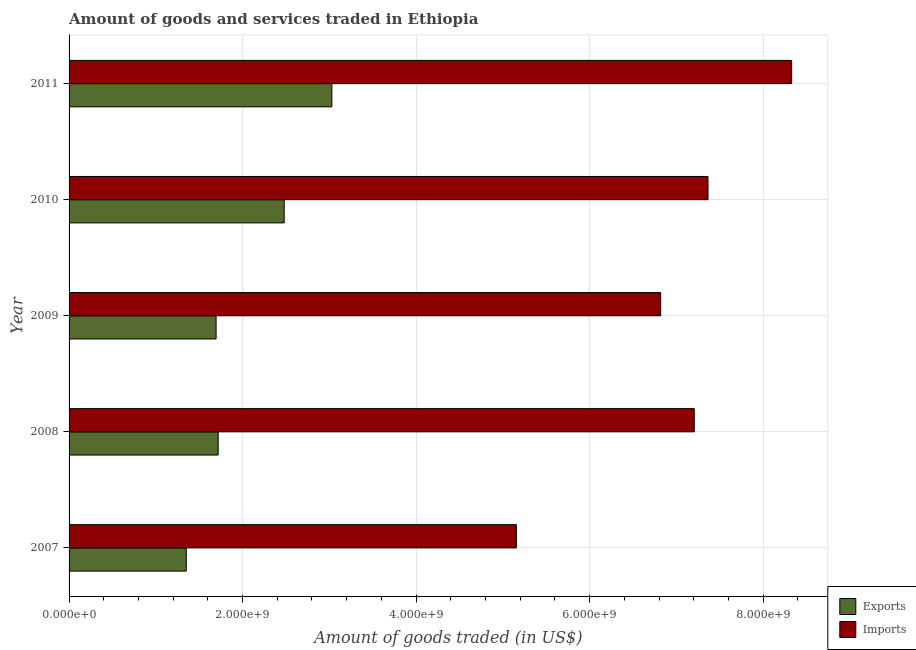How many different coloured bars are there?
Provide a short and direct response. 2. How many groups of bars are there?
Offer a terse response. 5. How many bars are there on the 5th tick from the bottom?
Your answer should be compact. 2. What is the amount of goods exported in 2007?
Offer a very short reply. 1.35e+09. Across all years, what is the maximum amount of goods exported?
Provide a short and direct response. 3.03e+09. Across all years, what is the minimum amount of goods imported?
Ensure brevity in your answer.  5.16e+09. In which year was the amount of goods imported maximum?
Give a very brief answer. 2011. What is the total amount of goods imported in the graph?
Make the answer very short. 3.49e+1. What is the difference between the amount of goods exported in 2010 and that in 2011?
Your answer should be very brief. -5.50e+08. What is the difference between the amount of goods exported in 2007 and the amount of goods imported in 2011?
Keep it short and to the point. -6.98e+09. What is the average amount of goods exported per year?
Provide a short and direct response. 2.05e+09. In the year 2010, what is the difference between the amount of goods exported and amount of goods imported?
Give a very brief answer. -4.89e+09. What is the ratio of the amount of goods exported in 2009 to that in 2010?
Give a very brief answer. 0.68. Is the amount of goods imported in 2008 less than that in 2009?
Your response must be concise. No. What is the difference between the highest and the second highest amount of goods exported?
Give a very brief answer. 5.50e+08. What is the difference between the highest and the lowest amount of goods exported?
Provide a short and direct response. 1.68e+09. What does the 2nd bar from the top in 2009 represents?
Provide a succinct answer. Exports. What does the 2nd bar from the bottom in 2008 represents?
Ensure brevity in your answer.  Imports. How many bars are there?
Your answer should be very brief. 10. Are all the bars in the graph horizontal?
Ensure brevity in your answer.  Yes. What is the difference between two consecutive major ticks on the X-axis?
Provide a succinct answer. 2.00e+09. Are the values on the major ticks of X-axis written in scientific E-notation?
Make the answer very short. Yes. Does the graph contain any zero values?
Ensure brevity in your answer.  No. Where does the legend appear in the graph?
Make the answer very short. Bottom right. How many legend labels are there?
Your answer should be compact. 2. What is the title of the graph?
Offer a terse response. Amount of goods and services traded in Ethiopia. What is the label or title of the X-axis?
Provide a succinct answer. Amount of goods traded (in US$). What is the Amount of goods traded (in US$) of Exports in 2007?
Your answer should be very brief. 1.35e+09. What is the Amount of goods traded (in US$) of Imports in 2007?
Provide a short and direct response. 5.16e+09. What is the Amount of goods traded (in US$) in Exports in 2008?
Keep it short and to the point. 1.72e+09. What is the Amount of goods traded (in US$) of Imports in 2008?
Your answer should be very brief. 7.21e+09. What is the Amount of goods traded (in US$) in Exports in 2009?
Offer a very short reply. 1.69e+09. What is the Amount of goods traded (in US$) in Imports in 2009?
Your response must be concise. 6.82e+09. What is the Amount of goods traded (in US$) of Exports in 2010?
Keep it short and to the point. 2.48e+09. What is the Amount of goods traded (in US$) of Imports in 2010?
Offer a very short reply. 7.36e+09. What is the Amount of goods traded (in US$) in Exports in 2011?
Your response must be concise. 3.03e+09. What is the Amount of goods traded (in US$) in Imports in 2011?
Make the answer very short. 8.33e+09. Across all years, what is the maximum Amount of goods traded (in US$) in Exports?
Provide a short and direct response. 3.03e+09. Across all years, what is the maximum Amount of goods traded (in US$) in Imports?
Provide a short and direct response. 8.33e+09. Across all years, what is the minimum Amount of goods traded (in US$) in Exports?
Your answer should be compact. 1.35e+09. Across all years, what is the minimum Amount of goods traded (in US$) in Imports?
Your answer should be very brief. 5.16e+09. What is the total Amount of goods traded (in US$) of Exports in the graph?
Give a very brief answer. 1.03e+1. What is the total Amount of goods traded (in US$) in Imports in the graph?
Your answer should be very brief. 3.49e+1. What is the difference between the Amount of goods traded (in US$) of Exports in 2007 and that in 2008?
Your answer should be compact. -3.68e+08. What is the difference between the Amount of goods traded (in US$) of Imports in 2007 and that in 2008?
Your response must be concise. -2.05e+09. What is the difference between the Amount of goods traded (in US$) of Exports in 2007 and that in 2009?
Your answer should be compact. -3.44e+08. What is the difference between the Amount of goods traded (in US$) in Imports in 2007 and that in 2009?
Keep it short and to the point. -1.66e+09. What is the difference between the Amount of goods traded (in US$) in Exports in 2007 and that in 2010?
Your answer should be very brief. -1.13e+09. What is the difference between the Amount of goods traded (in US$) of Imports in 2007 and that in 2010?
Keep it short and to the point. -2.21e+09. What is the difference between the Amount of goods traded (in US$) of Exports in 2007 and that in 2011?
Provide a short and direct response. -1.68e+09. What is the difference between the Amount of goods traded (in US$) of Imports in 2007 and that in 2011?
Provide a succinct answer. -3.17e+09. What is the difference between the Amount of goods traded (in US$) in Exports in 2008 and that in 2009?
Give a very brief answer. 2.39e+07. What is the difference between the Amount of goods traded (in US$) in Imports in 2008 and that in 2009?
Give a very brief answer. 3.87e+08. What is the difference between the Amount of goods traded (in US$) of Exports in 2008 and that in 2010?
Give a very brief answer. -7.61e+08. What is the difference between the Amount of goods traded (in US$) in Imports in 2008 and that in 2010?
Your response must be concise. -1.58e+08. What is the difference between the Amount of goods traded (in US$) in Exports in 2008 and that in 2011?
Your answer should be compact. -1.31e+09. What is the difference between the Amount of goods traded (in US$) in Imports in 2008 and that in 2011?
Provide a short and direct response. -1.12e+09. What is the difference between the Amount of goods traded (in US$) of Exports in 2009 and that in 2010?
Provide a succinct answer. -7.85e+08. What is the difference between the Amount of goods traded (in US$) of Imports in 2009 and that in 2010?
Provide a short and direct response. -5.45e+08. What is the difference between the Amount of goods traded (in US$) of Exports in 2009 and that in 2011?
Your answer should be very brief. -1.33e+09. What is the difference between the Amount of goods traded (in US$) in Imports in 2009 and that in 2011?
Your answer should be very brief. -1.51e+09. What is the difference between the Amount of goods traded (in US$) of Exports in 2010 and that in 2011?
Keep it short and to the point. -5.50e+08. What is the difference between the Amount of goods traded (in US$) in Imports in 2010 and that in 2011?
Provide a short and direct response. -9.64e+08. What is the difference between the Amount of goods traded (in US$) in Exports in 2007 and the Amount of goods traded (in US$) in Imports in 2008?
Offer a terse response. -5.86e+09. What is the difference between the Amount of goods traded (in US$) in Exports in 2007 and the Amount of goods traded (in US$) in Imports in 2009?
Provide a short and direct response. -5.47e+09. What is the difference between the Amount of goods traded (in US$) of Exports in 2007 and the Amount of goods traded (in US$) of Imports in 2010?
Give a very brief answer. -6.01e+09. What is the difference between the Amount of goods traded (in US$) in Exports in 2007 and the Amount of goods traded (in US$) in Imports in 2011?
Offer a terse response. -6.98e+09. What is the difference between the Amount of goods traded (in US$) in Exports in 2008 and the Amount of goods traded (in US$) in Imports in 2009?
Ensure brevity in your answer.  -5.10e+09. What is the difference between the Amount of goods traded (in US$) of Exports in 2008 and the Amount of goods traded (in US$) of Imports in 2010?
Offer a very short reply. -5.65e+09. What is the difference between the Amount of goods traded (in US$) of Exports in 2008 and the Amount of goods traded (in US$) of Imports in 2011?
Keep it short and to the point. -6.61e+09. What is the difference between the Amount of goods traded (in US$) of Exports in 2009 and the Amount of goods traded (in US$) of Imports in 2010?
Your answer should be compact. -5.67e+09. What is the difference between the Amount of goods traded (in US$) in Exports in 2009 and the Amount of goods traded (in US$) in Imports in 2011?
Your answer should be compact. -6.63e+09. What is the difference between the Amount of goods traded (in US$) in Exports in 2010 and the Amount of goods traded (in US$) in Imports in 2011?
Give a very brief answer. -5.85e+09. What is the average Amount of goods traded (in US$) of Exports per year?
Keep it short and to the point. 2.05e+09. What is the average Amount of goods traded (in US$) in Imports per year?
Your answer should be compact. 6.97e+09. In the year 2007, what is the difference between the Amount of goods traded (in US$) of Exports and Amount of goods traded (in US$) of Imports?
Offer a terse response. -3.80e+09. In the year 2008, what is the difference between the Amount of goods traded (in US$) in Exports and Amount of goods traded (in US$) in Imports?
Offer a terse response. -5.49e+09. In the year 2009, what is the difference between the Amount of goods traded (in US$) of Exports and Amount of goods traded (in US$) of Imports?
Your answer should be very brief. -5.12e+09. In the year 2010, what is the difference between the Amount of goods traded (in US$) of Exports and Amount of goods traded (in US$) of Imports?
Your response must be concise. -4.89e+09. In the year 2011, what is the difference between the Amount of goods traded (in US$) in Exports and Amount of goods traded (in US$) in Imports?
Make the answer very short. -5.30e+09. What is the ratio of the Amount of goods traded (in US$) of Exports in 2007 to that in 2008?
Make the answer very short. 0.79. What is the ratio of the Amount of goods traded (in US$) in Imports in 2007 to that in 2008?
Keep it short and to the point. 0.72. What is the ratio of the Amount of goods traded (in US$) in Exports in 2007 to that in 2009?
Make the answer very short. 0.8. What is the ratio of the Amount of goods traded (in US$) in Imports in 2007 to that in 2009?
Your response must be concise. 0.76. What is the ratio of the Amount of goods traded (in US$) in Exports in 2007 to that in 2010?
Your answer should be very brief. 0.54. What is the ratio of the Amount of goods traded (in US$) in Imports in 2007 to that in 2010?
Your answer should be very brief. 0.7. What is the ratio of the Amount of goods traded (in US$) in Exports in 2007 to that in 2011?
Your answer should be very brief. 0.45. What is the ratio of the Amount of goods traded (in US$) in Imports in 2007 to that in 2011?
Keep it short and to the point. 0.62. What is the ratio of the Amount of goods traded (in US$) in Exports in 2008 to that in 2009?
Provide a short and direct response. 1.01. What is the ratio of the Amount of goods traded (in US$) in Imports in 2008 to that in 2009?
Make the answer very short. 1.06. What is the ratio of the Amount of goods traded (in US$) in Exports in 2008 to that in 2010?
Provide a short and direct response. 0.69. What is the ratio of the Amount of goods traded (in US$) in Imports in 2008 to that in 2010?
Give a very brief answer. 0.98. What is the ratio of the Amount of goods traded (in US$) of Exports in 2008 to that in 2011?
Keep it short and to the point. 0.57. What is the ratio of the Amount of goods traded (in US$) of Imports in 2008 to that in 2011?
Ensure brevity in your answer.  0.87. What is the ratio of the Amount of goods traded (in US$) of Exports in 2009 to that in 2010?
Your answer should be very brief. 0.68. What is the ratio of the Amount of goods traded (in US$) in Imports in 2009 to that in 2010?
Your response must be concise. 0.93. What is the ratio of the Amount of goods traded (in US$) in Exports in 2009 to that in 2011?
Provide a short and direct response. 0.56. What is the ratio of the Amount of goods traded (in US$) of Imports in 2009 to that in 2011?
Offer a terse response. 0.82. What is the ratio of the Amount of goods traded (in US$) in Exports in 2010 to that in 2011?
Ensure brevity in your answer.  0.82. What is the ratio of the Amount of goods traded (in US$) in Imports in 2010 to that in 2011?
Give a very brief answer. 0.88. What is the difference between the highest and the second highest Amount of goods traded (in US$) in Exports?
Your response must be concise. 5.50e+08. What is the difference between the highest and the second highest Amount of goods traded (in US$) in Imports?
Provide a succinct answer. 9.64e+08. What is the difference between the highest and the lowest Amount of goods traded (in US$) in Exports?
Your answer should be compact. 1.68e+09. What is the difference between the highest and the lowest Amount of goods traded (in US$) in Imports?
Keep it short and to the point. 3.17e+09. 